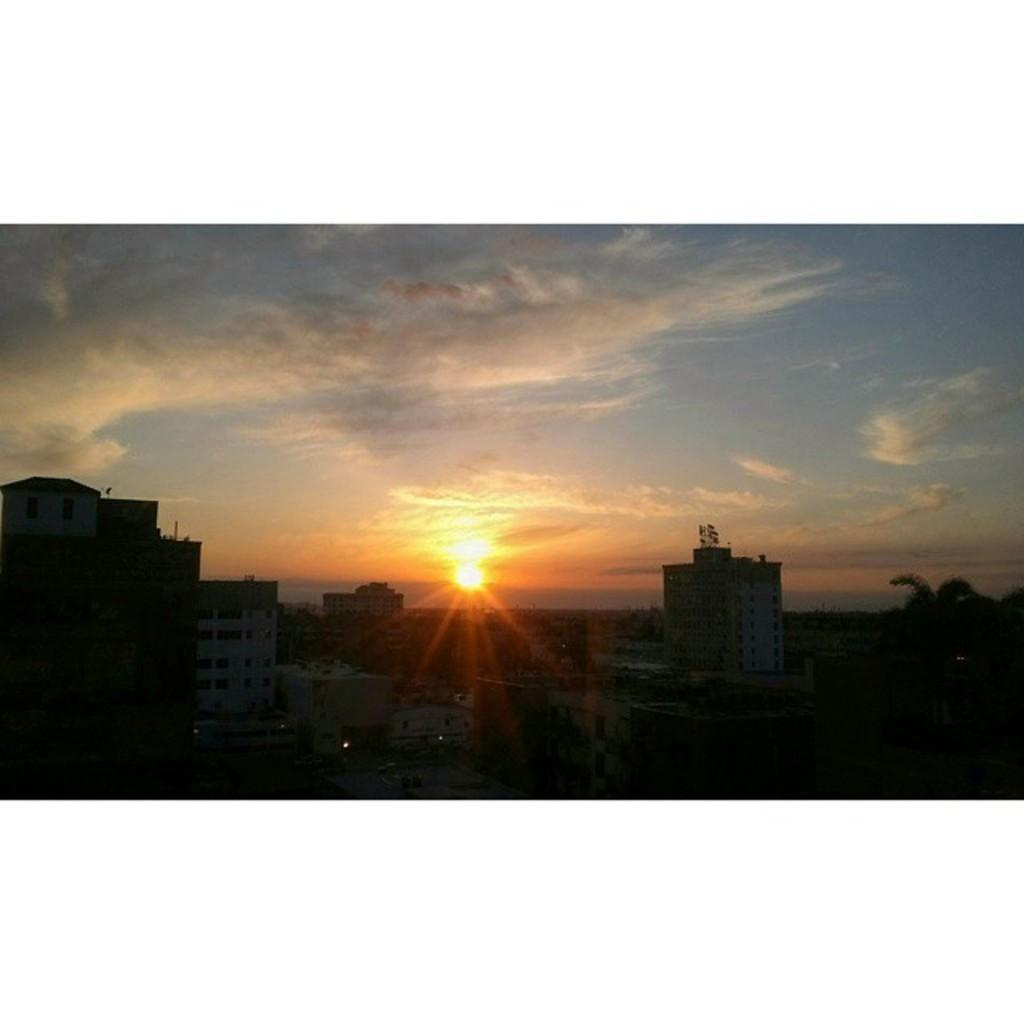What type of environment is depicted in the image? The image is an outside view. What structures can be seen in the image? There are many buildings in the image. What type of vegetation is present in the image? There are trees in the image. Can you describe the lighting conditions in the image? The image is set in a dark environment. What is visible in the sky in the image? The sky is visible in the image, and the sun and clouds are observable. What type of mask is being worn by the trees in the image? There are no masks present in the image, as it features buildings, trees, and a sky with clouds and the sun. What type of learning is taking place in the image? There is no learning activity depicted in the image; it is a view of buildings, trees, and the sky. 